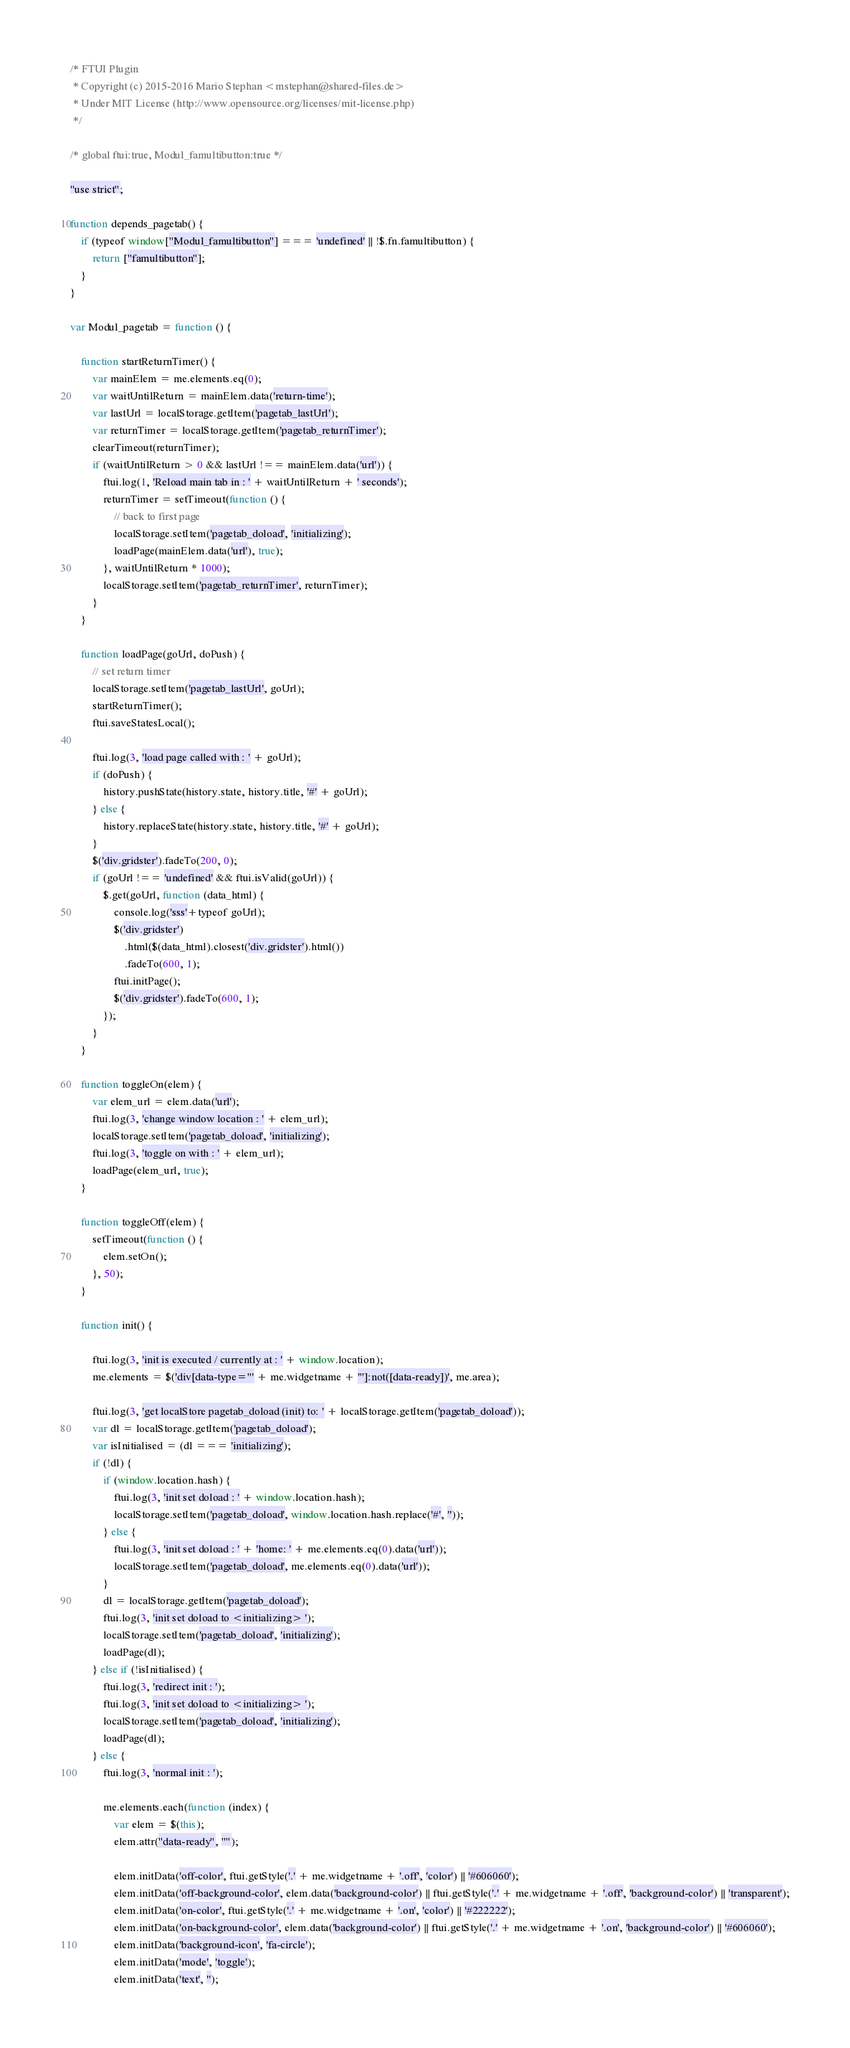<code> <loc_0><loc_0><loc_500><loc_500><_JavaScript_>/* FTUI Plugin
 * Copyright (c) 2015-2016 Mario Stephan <mstephan@shared-files.de>
 * Under MIT License (http://www.opensource.org/licenses/mit-license.php)
 */

/* global ftui:true, Modul_famultibutton:true */

"use strict";

function depends_pagetab() {
    if (typeof window["Modul_famultibutton"] === 'undefined' || !$.fn.famultibutton) {
        return ["famultibutton"];
    }
}

var Modul_pagetab = function () {

    function startReturnTimer() {
        var mainElem = me.elements.eq(0);
        var waitUntilReturn = mainElem.data('return-time');
        var lastUrl = localStorage.getItem('pagetab_lastUrl');
        var returnTimer = localStorage.getItem('pagetab_returnTimer');
        clearTimeout(returnTimer);
        if (waitUntilReturn > 0 && lastUrl !== mainElem.data('url')) {
            ftui.log(1, 'Reload main tab in : ' + waitUntilReturn + ' seconds');
            returnTimer = setTimeout(function () {
                // back to first page
                localStorage.setItem('pagetab_doload', 'initializing');
                loadPage(mainElem.data('url'), true);
            }, waitUntilReturn * 1000);
            localStorage.setItem('pagetab_returnTimer', returnTimer);
        }
    }

    function loadPage(goUrl, doPush) {
        // set return timer
        localStorage.setItem('pagetab_lastUrl', goUrl);
        startReturnTimer();
        ftui.saveStatesLocal();

        ftui.log(3, 'load page called with : ' + goUrl);
        if (doPush) {
            history.pushState(history.state, history.title, '#' + goUrl);
        } else {
            history.replaceState(history.state, history.title, '#' + goUrl);
        }
        $('div.gridster').fadeTo(200, 0);
        if (goUrl !== 'undefined' && ftui.isValid(goUrl)) {
            $.get(goUrl, function (data_html) {
                console.log('sss'+typeof goUrl);
                $('div.gridster')
                    .html($(data_html).closest('div.gridster').html())
                    .fadeTo(600, 1);
                ftui.initPage();
                $('div.gridster').fadeTo(600, 1);
            });
        }
    }

    function toggleOn(elem) {
        var elem_url = elem.data('url');
        ftui.log(3, 'change window location : ' + elem_url);
        localStorage.setItem('pagetab_doload', 'initializing');
        ftui.log(3, 'toggle on with : ' + elem_url);
        loadPage(elem_url, true);
    }

    function toggleOff(elem) {
        setTimeout(function () {
            elem.setOn();
        }, 50);
    }

    function init() {

        ftui.log(3, 'init is executed / currently at : ' + window.location);
        me.elements = $('div[data-type="' + me.widgetname + '"]:not([data-ready])', me.area);

        ftui.log(3, 'get localStore pagetab_doload (init) to: ' + localStorage.getItem('pagetab_doload'));
        var dl = localStorage.getItem('pagetab_doload');
        var isInitialised = (dl === 'initializing');
        if (!dl) {
            if (window.location.hash) {
                ftui.log(3, 'init set doload : ' + window.location.hash);
                localStorage.setItem('pagetab_doload', window.location.hash.replace('#', ''));
            } else {
                ftui.log(3, 'init set doload : ' + 'home: ' + me.elements.eq(0).data('url'));
                localStorage.setItem('pagetab_doload', me.elements.eq(0).data('url'));
            }
            dl = localStorage.getItem('pagetab_doload');
            ftui.log(3, 'init set doload to <initializing> ');
            localStorage.setItem('pagetab_doload', 'initializing');
            loadPage(dl);
        } else if (!isInitialised) {
            ftui.log(3, 'redirect init : ');
            ftui.log(3, 'init set doload to <initializing> ');
            localStorage.setItem('pagetab_doload', 'initializing');
            loadPage(dl);
        } else {
            ftui.log(3, 'normal init : ');

            me.elements.each(function (index) {
                var elem = $(this);
                elem.attr("data-ready", "");
                
                elem.initData('off-color', ftui.getStyle('.' + me.widgetname + '.off', 'color') || '#606060');
                elem.initData('off-background-color', elem.data('background-color') || ftui.getStyle('.' + me.widgetname + '.off', 'background-color') || 'transparent');
                elem.initData('on-color', ftui.getStyle('.' + me.widgetname + '.on', 'color') || '#222222');
                elem.initData('on-background-color', elem.data('background-color') || ftui.getStyle('.' + me.widgetname + '.on', 'background-color') || '#606060');
                elem.initData('background-icon', 'fa-circle');
                elem.initData('mode', 'toggle');
                elem.initData('text', '');</code> 